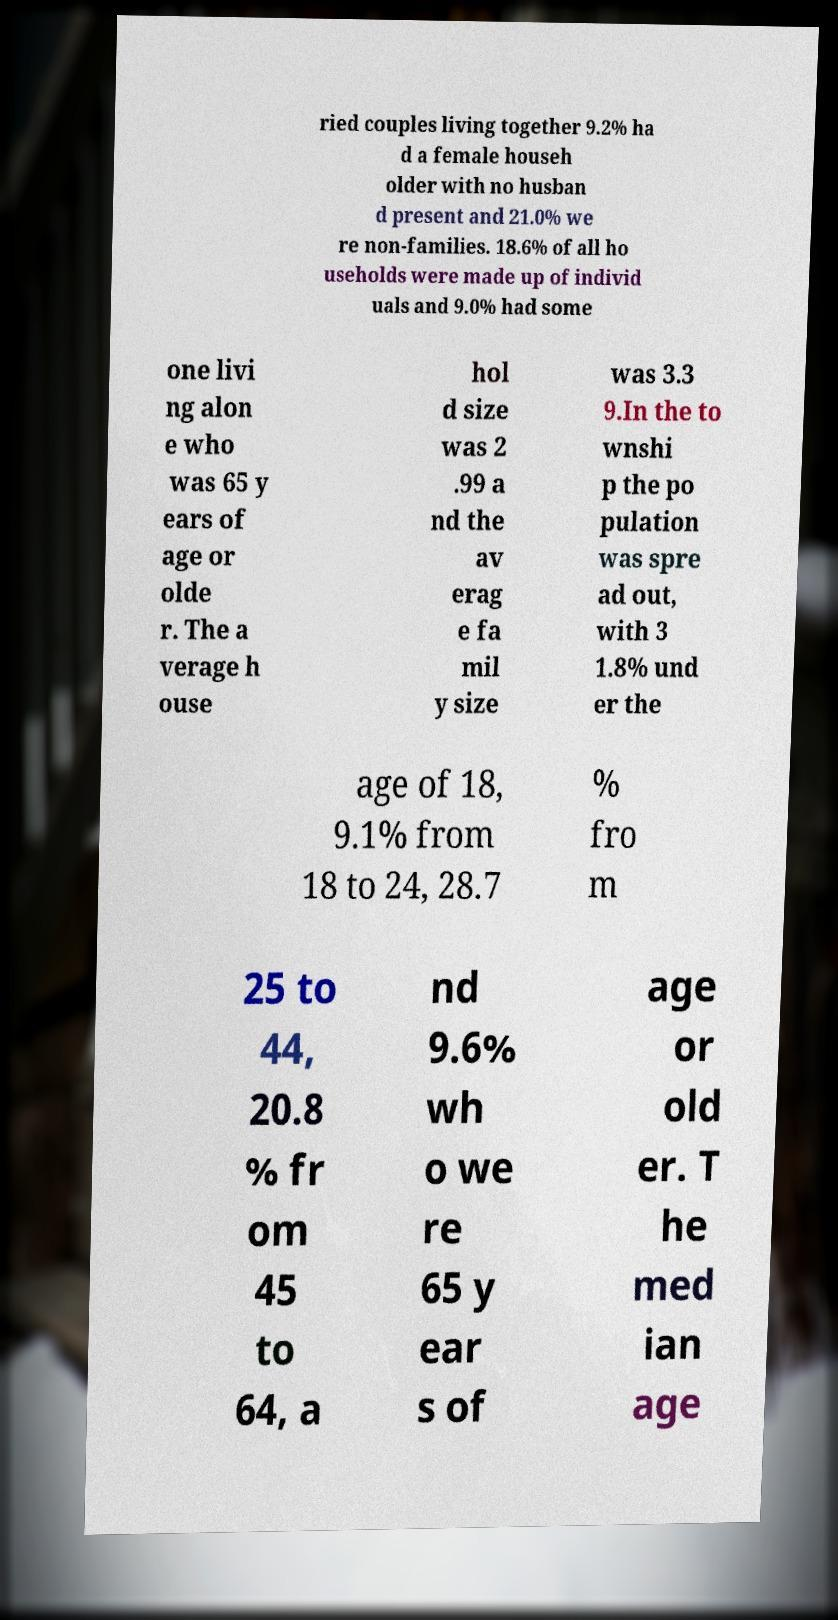Please identify and transcribe the text found in this image. ried couples living together 9.2% ha d a female househ older with no husban d present and 21.0% we re non-families. 18.6% of all ho useholds were made up of individ uals and 9.0% had some one livi ng alon e who was 65 y ears of age or olde r. The a verage h ouse hol d size was 2 .99 a nd the av erag e fa mil y size was 3.3 9.In the to wnshi p the po pulation was spre ad out, with 3 1.8% und er the age of 18, 9.1% from 18 to 24, 28.7 % fro m 25 to 44, 20.8 % fr om 45 to 64, a nd 9.6% wh o we re 65 y ear s of age or old er. T he med ian age 